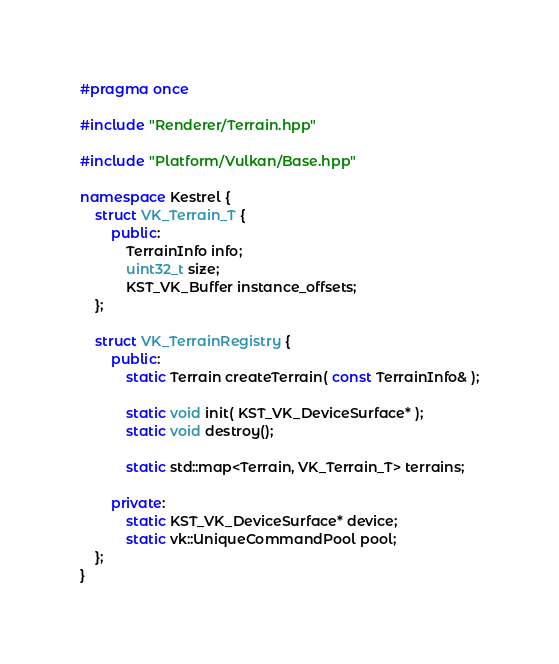<code> <loc_0><loc_0><loc_500><loc_500><_C++_>#pragma once

#include "Renderer/Terrain.hpp"

#include "Platform/Vulkan/Base.hpp"

namespace Kestrel {
	struct VK_Terrain_T {
		public:
			TerrainInfo info;
			uint32_t size;
			KST_VK_Buffer instance_offsets;
	};

	struct VK_TerrainRegistry {
		public:
			static Terrain createTerrain( const TerrainInfo& );

			static void init( KST_VK_DeviceSurface* );
			static void destroy();

			static std::map<Terrain, VK_Terrain_T> terrains;

		private:
			static KST_VK_DeviceSurface* device;
			static vk::UniqueCommandPool pool;
	};
}
</code> 